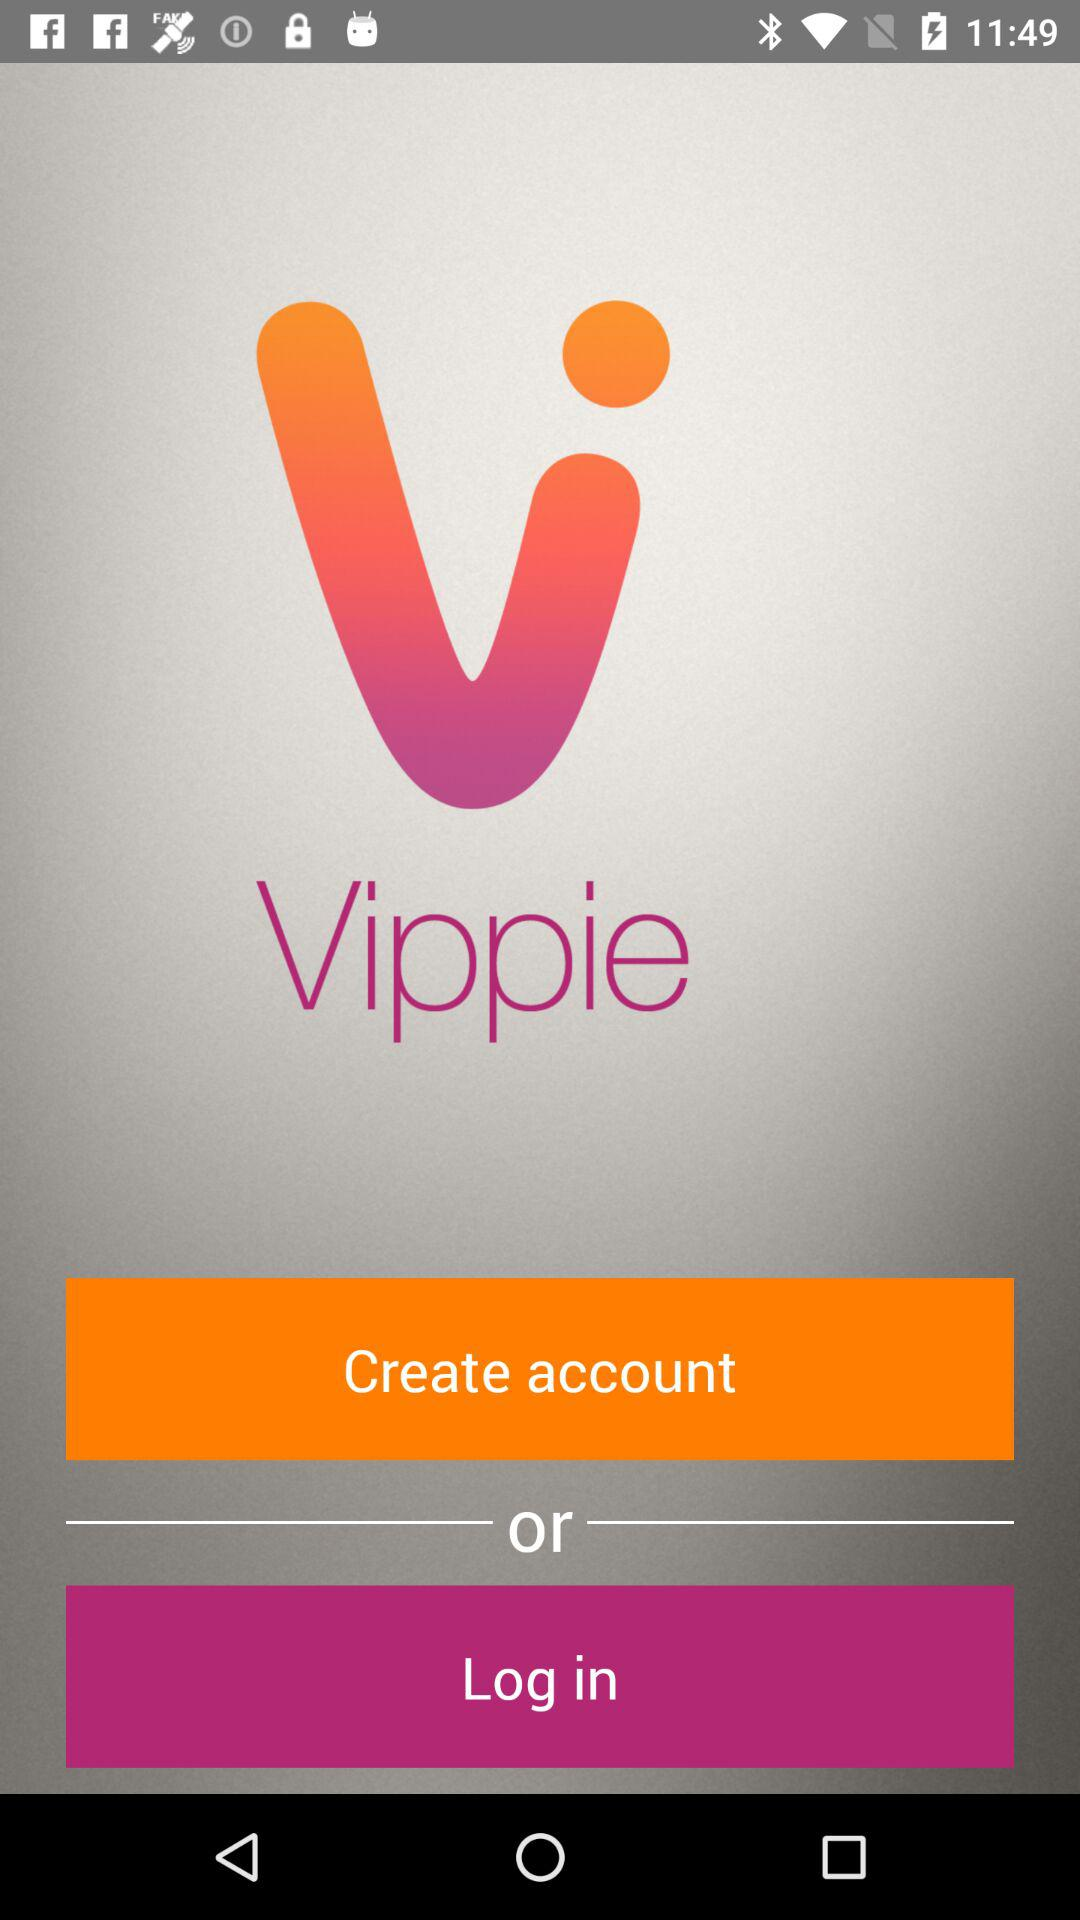What is the name of the application? The name of the application is "Vippie". 